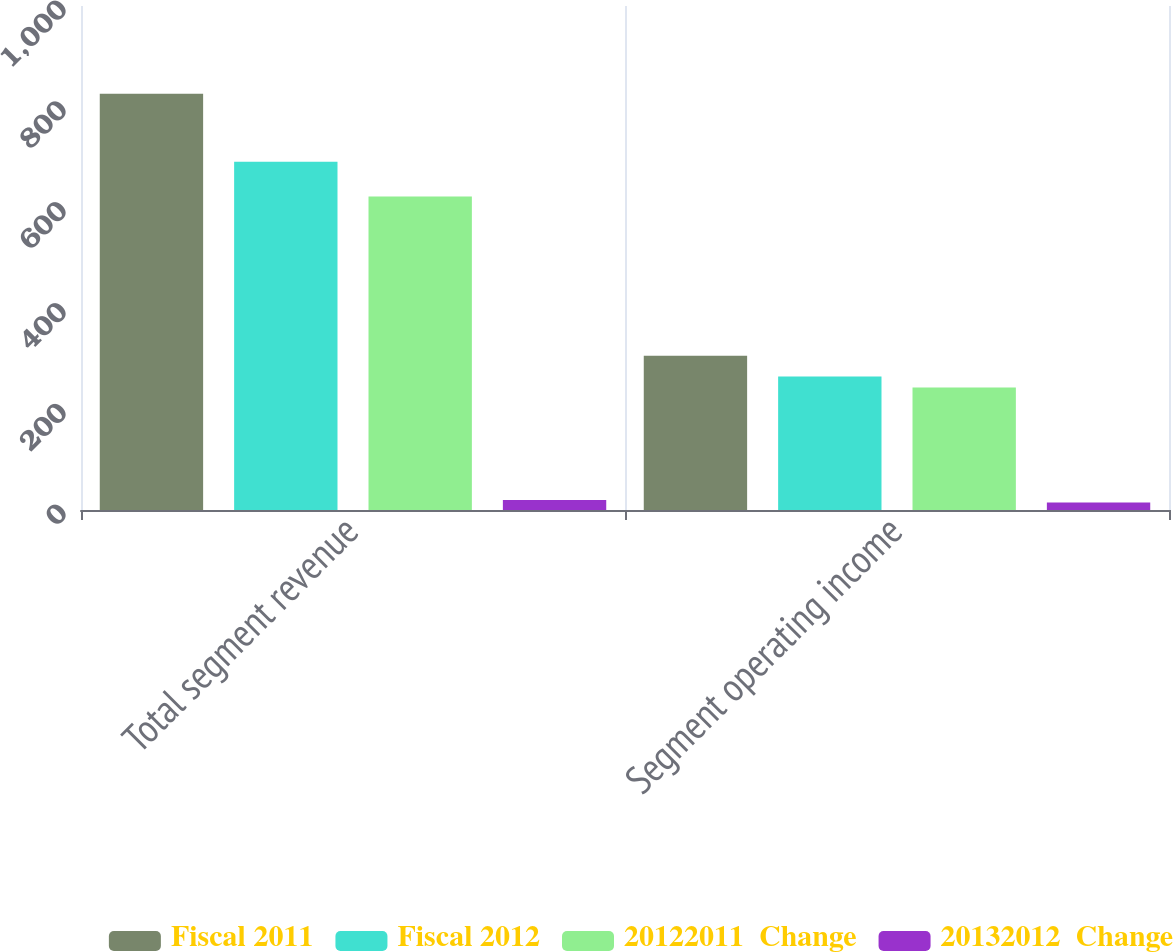Convert chart to OTSL. <chart><loc_0><loc_0><loc_500><loc_500><stacked_bar_chart><ecel><fcel>Total segment revenue<fcel>Segment operating income<nl><fcel>Fiscal 2011<fcel>826<fcel>306<nl><fcel>Fiscal 2012<fcel>691<fcel>265<nl><fcel>20122011  Change<fcel>622<fcel>243<nl><fcel>20132012  Change<fcel>20<fcel>15<nl></chart> 